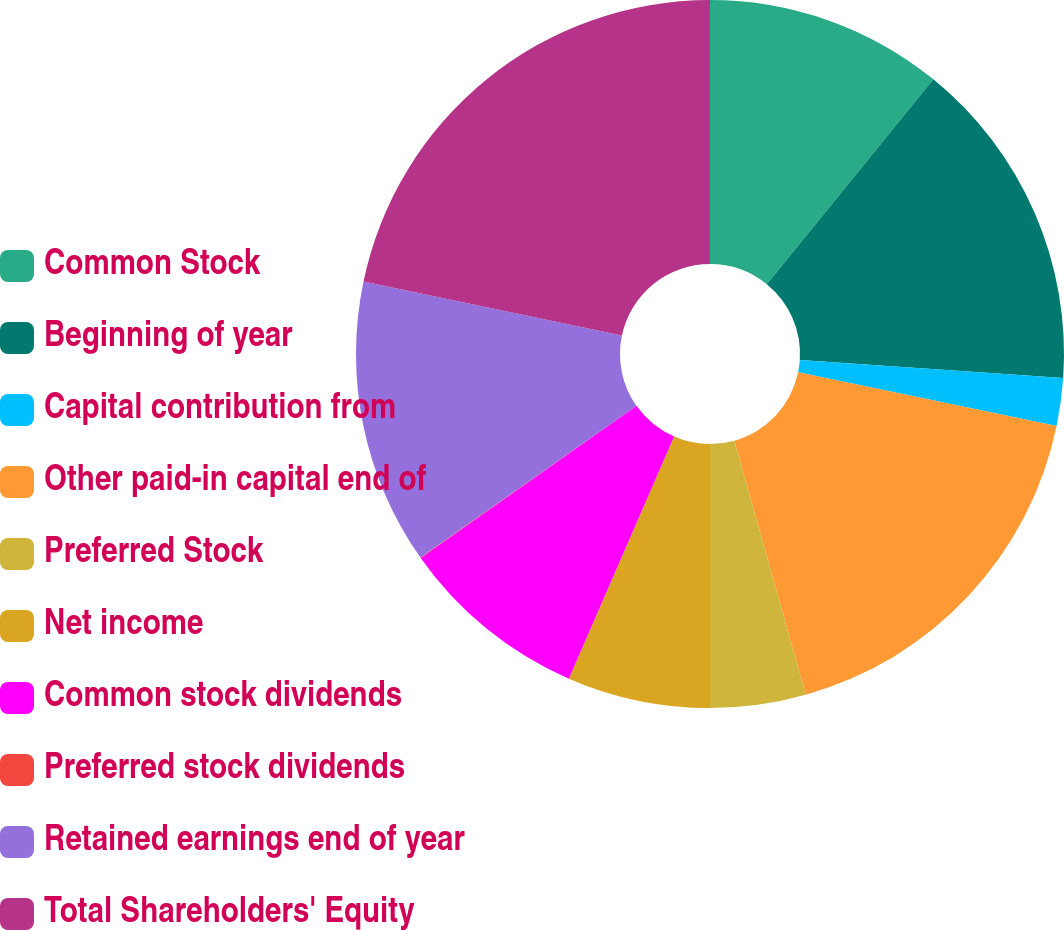Convert chart. <chart><loc_0><loc_0><loc_500><loc_500><pie_chart><fcel>Common Stock<fcel>Beginning of year<fcel>Capital contribution from<fcel>Other paid-in capital end of<fcel>Preferred Stock<fcel>Net income<fcel>Common stock dividends<fcel>Preferred stock dividends<fcel>Retained earnings end of year<fcel>Total Shareholders' Equity<nl><fcel>10.87%<fcel>15.21%<fcel>2.19%<fcel>17.38%<fcel>4.36%<fcel>6.53%<fcel>8.7%<fcel>0.02%<fcel>13.04%<fcel>21.72%<nl></chart> 